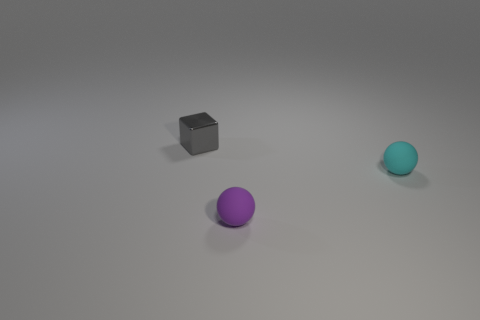There is a purple object; is it the same shape as the tiny gray shiny object behind the cyan rubber thing?
Offer a terse response. No. There is a ball that is the same material as the small cyan object; what is its color?
Provide a succinct answer. Purple. Is the material of the small cyan thing the same as the tiny ball to the left of the cyan sphere?
Provide a succinct answer. Yes. What number of things are both behind the purple matte thing and in front of the tiny gray metal object?
Your answer should be compact. 1. There is a purple thing that is the same size as the gray cube; what shape is it?
Your response must be concise. Sphere. Are there any balls behind the small ball that is to the left of the small sphere that is behind the purple matte thing?
Offer a very short reply. Yes. There is a rubber sphere behind the small ball that is in front of the tiny cyan sphere; what size is it?
Ensure brevity in your answer.  Small. How many objects are either small objects that are in front of the gray block or small blocks?
Your answer should be compact. 3. Is there a object that has the same size as the metal cube?
Provide a short and direct response. Yes. Is there a tiny cyan sphere on the right side of the tiny sphere that is in front of the cyan thing?
Your response must be concise. Yes. 